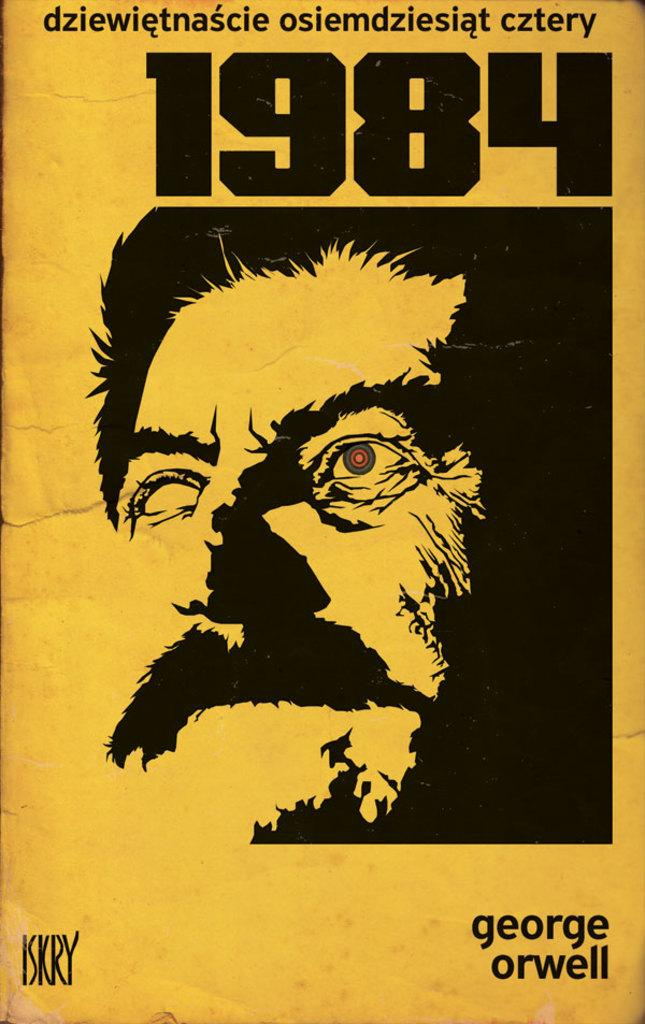<image>
Share a concise interpretation of the image provided. A German language copy of 1984 by George Orwell. 